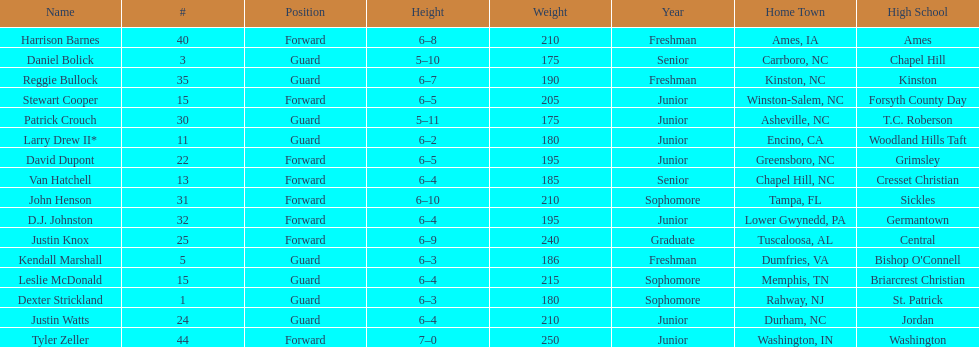How many players have a weight exceeding 200? 7. Parse the table in full. {'header': ['Name', '#', 'Position', 'Height', 'Weight', 'Year', 'Home Town', 'High School'], 'rows': [['Harrison Barnes', '40', 'Forward', '6–8', '210', 'Freshman', 'Ames, IA', 'Ames'], ['Daniel Bolick', '3', 'Guard', '5–10', '175', 'Senior', 'Carrboro, NC', 'Chapel Hill'], ['Reggie Bullock', '35', 'Guard', '6–7', '190', 'Freshman', 'Kinston, NC', 'Kinston'], ['Stewart Cooper', '15', 'Forward', '6–5', '205', 'Junior', 'Winston-Salem, NC', 'Forsyth County Day'], ['Patrick Crouch', '30', 'Guard', '5–11', '175', 'Junior', 'Asheville, NC', 'T.C. Roberson'], ['Larry Drew II*', '11', 'Guard', '6–2', '180', 'Junior', 'Encino, CA', 'Woodland Hills Taft'], ['David Dupont', '22', 'Forward', '6–5', '195', 'Junior', 'Greensboro, NC', 'Grimsley'], ['Van Hatchell', '13', 'Forward', '6–4', '185', 'Senior', 'Chapel Hill, NC', 'Cresset Christian'], ['John Henson', '31', 'Forward', '6–10', '210', 'Sophomore', 'Tampa, FL', 'Sickles'], ['D.J. Johnston', '32', 'Forward', '6–4', '195', 'Junior', 'Lower Gwynedd, PA', 'Germantown'], ['Justin Knox', '25', 'Forward', '6–9', '240', 'Graduate', 'Tuscaloosa, AL', 'Central'], ['Kendall Marshall', '5', 'Guard', '6–3', '186', 'Freshman', 'Dumfries, VA', "Bishop O'Connell"], ['Leslie McDonald', '15', 'Guard', '6–4', '215', 'Sophomore', 'Memphis, TN', 'Briarcrest Christian'], ['Dexter Strickland', '1', 'Guard', '6–3', '180', 'Sophomore', 'Rahway, NJ', 'St. Patrick'], ['Justin Watts', '24', 'Guard', '6–4', '210', 'Junior', 'Durham, NC', 'Jordan'], ['Tyler Zeller', '44', 'Forward', '7–0', '250', 'Junior', 'Washington, IN', 'Washington']]} 